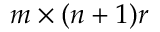Convert formula to latex. <formula><loc_0><loc_0><loc_500><loc_500>m \times ( n + 1 ) r</formula> 